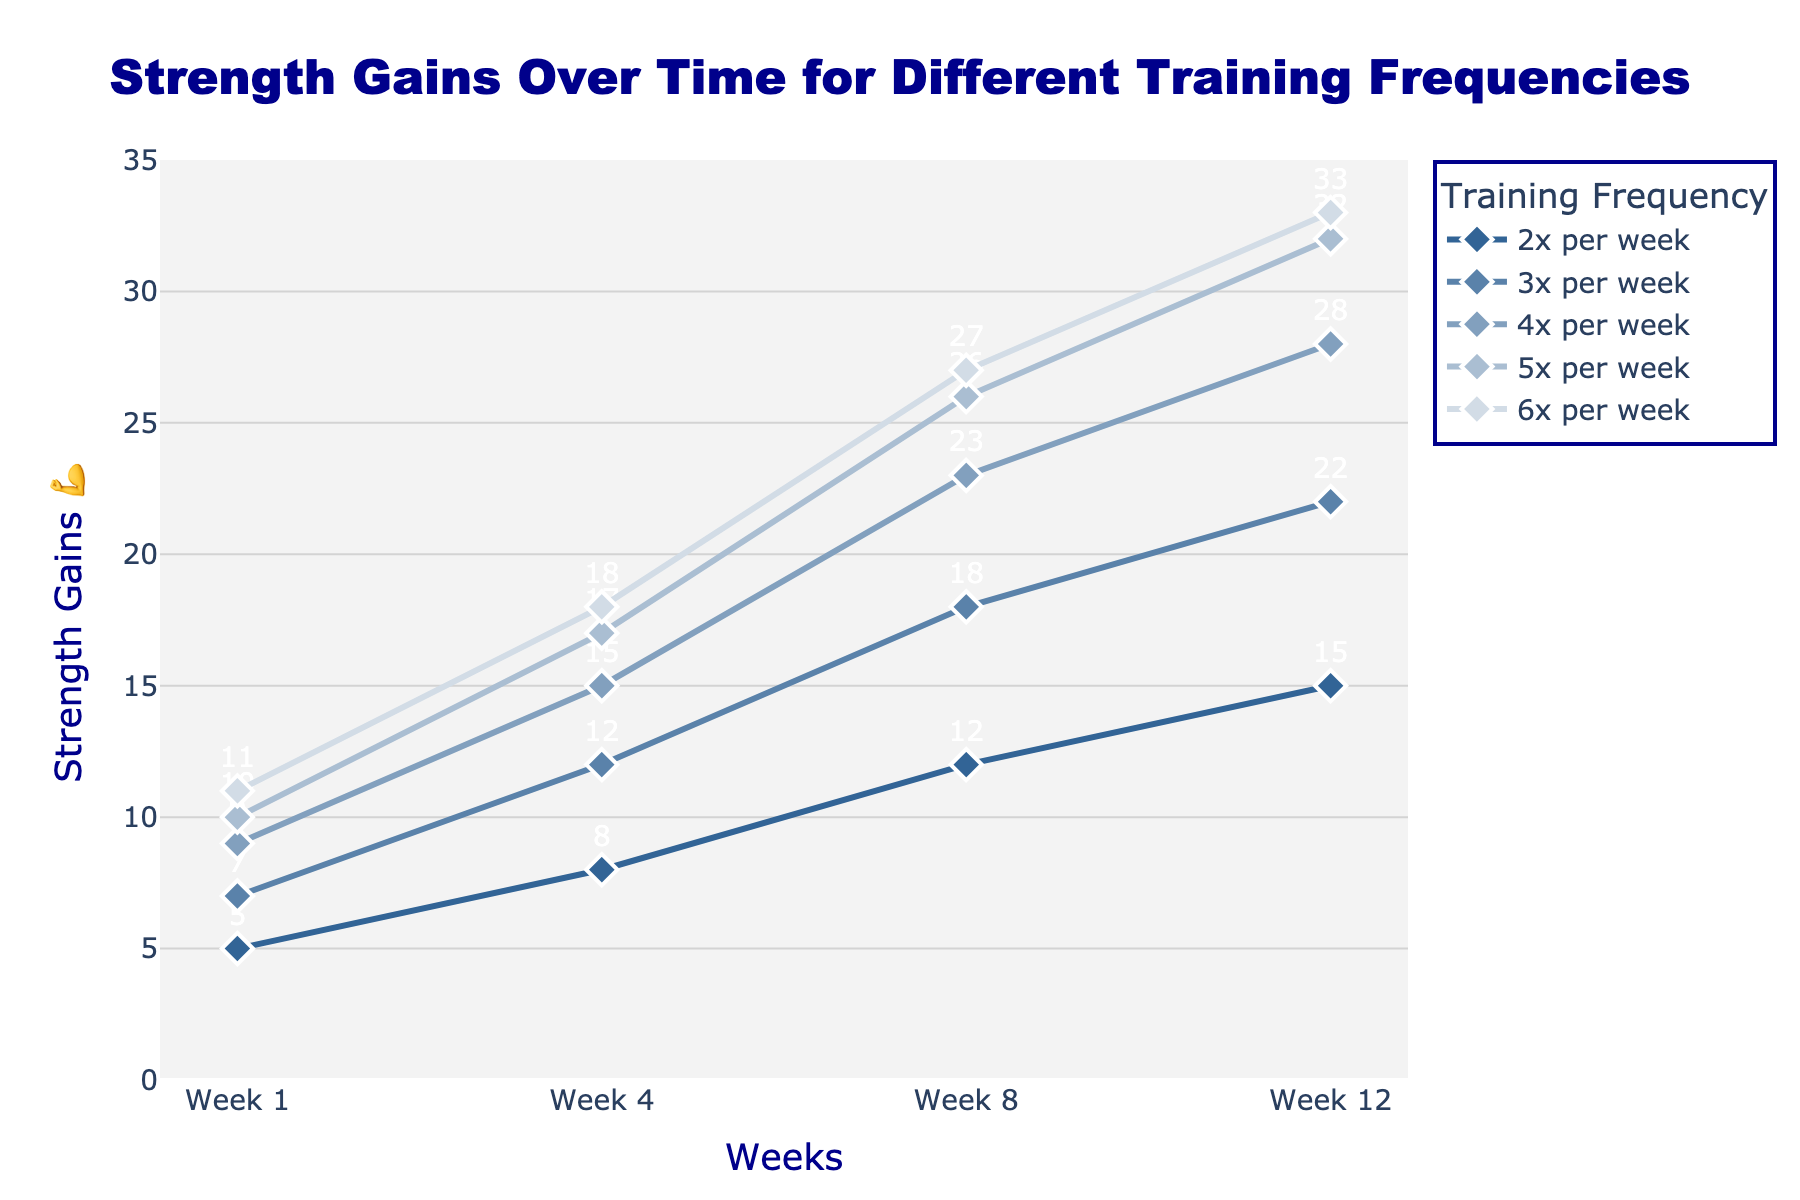What's the title of the figure? The title is often at the top center of the figure and is used to indicate the main topic. The title here is "Strength Gains Over Time for Different Training Frequencies".
Answer: Strength Gains Over Time for Different Training Frequencies What is on the y-axis? The y-axis typically represents the variable being measured, and in this figure, it is labeled as "Strength Gains 💪".
Answer: Strength Gains 💪 Which training frequency shows the highest strength gains by Week 12? To find this, look at the values for Week 12 for each training frequency. The highest value is 33 for 6x per week.
Answer: 6x per week How does the strength gain for training 3 times per week compare between Week 1 and Week 12? To answer this, subtract the Week 1 value (7) from the Week 12 value (22). This gives a strength gain difference of 15.
Answer: 15 On average, how much strength is gained per week for someone training 5 times per week from Week 1 to Week 12? Calculate the total gain from Week 1 (10) to Week 12 (32), which is 32 - 10 = 22. Since it's over 11 weeks, divide 22 by 11 to get the average per week.
Answer: 2 What’s the difference in strength gains between those who train 4 times per week and 6 times per week by Week 8? Subtract the value for 4x (23) from the value for 6x (27). The difference is 4.
Answer: 4 In Week 4, which training frequency resulted in higher strength gains than training 2 times per week but lower than training 5 times per week? Looking at Week 4, training 3x (12) and 4x (15) fit this criterion. Training 2x gains 8 and 5x gains 17 in Week 4.
Answer: 3x and 4x Between which weeks does the training frequency of 3 times per week show the largest strength gain? Calculate the weekly gains: Week 1-4 (12-7=5), Week 4-8 (18-12=6), Week 8-12 (22-18=4). Largest gain is between Week 4 and Week 8.
Answer: Week 4 and Week 8 Which training frequency shows a linear growth pattern in strength gains? By examining the growth patterns, it’s clear that the 6x per week shows consistent linear increases: 11 (Week 1), 18 (Week 4), 27 (Week 8), 33 (Week 12).
Answer: 6x per week 